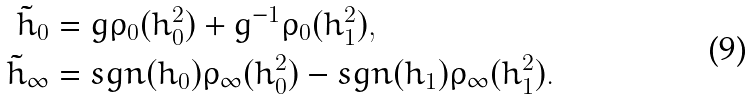<formula> <loc_0><loc_0><loc_500><loc_500>\tilde { h } _ { 0 } & = g \rho _ { 0 } ( h _ { 0 } ^ { 2 } ) + g ^ { - 1 } \rho _ { 0 } ( h _ { 1 } ^ { 2 } ) , \\ \tilde { h } _ { \infty } & = s g n ( h _ { 0 } ) \rho _ { \infty } ( h _ { 0 } ^ { 2 } ) - s g n ( h _ { 1 } ) \rho _ { \infty } ( h _ { 1 } ^ { 2 } ) .</formula> 